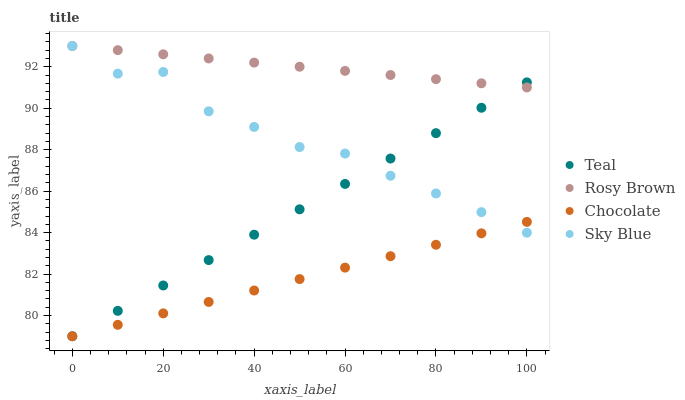Does Chocolate have the minimum area under the curve?
Answer yes or no. Yes. Does Rosy Brown have the maximum area under the curve?
Answer yes or no. Yes. Does Teal have the minimum area under the curve?
Answer yes or no. No. Does Teal have the maximum area under the curve?
Answer yes or no. No. Is Teal the smoothest?
Answer yes or no. Yes. Is Sky Blue the roughest?
Answer yes or no. Yes. Is Rosy Brown the smoothest?
Answer yes or no. No. Is Rosy Brown the roughest?
Answer yes or no. No. Does Teal have the lowest value?
Answer yes or no. Yes. Does Rosy Brown have the lowest value?
Answer yes or no. No. Does Rosy Brown have the highest value?
Answer yes or no. Yes. Does Teal have the highest value?
Answer yes or no. No. Is Chocolate less than Rosy Brown?
Answer yes or no. Yes. Is Rosy Brown greater than Chocolate?
Answer yes or no. Yes. Does Teal intersect Sky Blue?
Answer yes or no. Yes. Is Teal less than Sky Blue?
Answer yes or no. No. Is Teal greater than Sky Blue?
Answer yes or no. No. Does Chocolate intersect Rosy Brown?
Answer yes or no. No. 